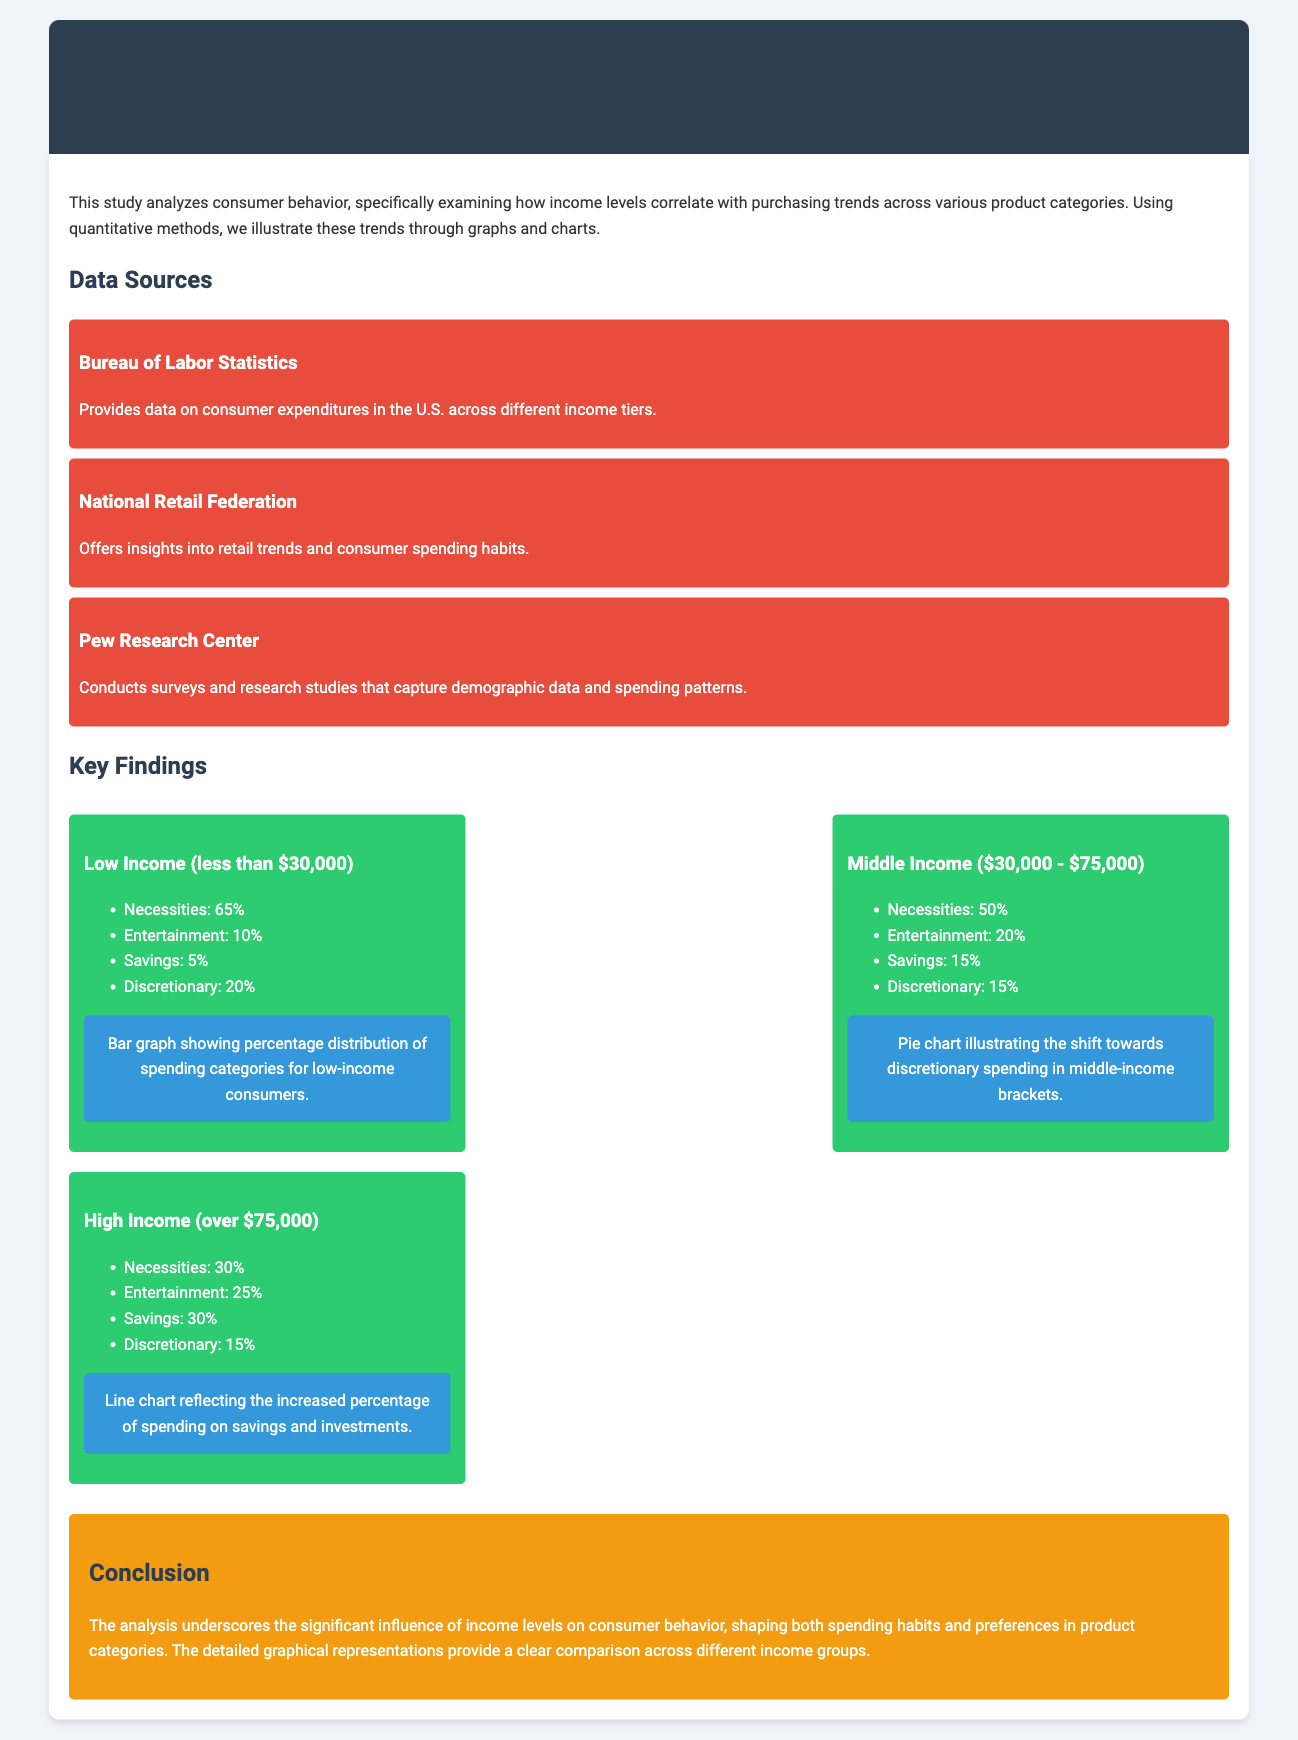What is the primary focus of the study? The study examines how income levels correlate with purchasing trends across various product categories.
Answer: Correlation between income levels and purchasing trends Which data source provides information on consumer expenditures in the U.S.? The document mentions the Bureau of Labor Statistics as a data source for consumer expenditures across income tiers.
Answer: Bureau of Labor Statistics What percentage of low-income consumers spend on necessities? The document states that 65% of low-income consumers allocate their spending to necessities.
Answer: 65% How much do high-income consumers allocate to entertainment? According to the findings, high-income consumers spend 25% on entertainment.
Answer: 25% What spending category sees the highest percentage for middle-income consumers? The analysis reveals that necessities account for 50% of spending among middle-income consumers.
Answer: Necessities Which chart type illustrates the shift towards discretionary spending in middle-income brackets? The document specifies that a pie chart is used to illustrate this shift.
Answer: Pie chart What is the income threshold for the high-income category in the study? The document states that the high-income category includes consumers earning over $75,000.
Answer: Over $75,000 What is the overall conclusion regarding income levels and consumer behavior? The conclusion emphasizes the significant influence of income levels on consumer behavior and spending habits.
Answer: Significant influence on consumer behavior How does high-income spending on savings compare to low-income spending? The findings indicate that high-income consumers spend 30% on savings, while low-income consumers spend 5%.
Answer: High-income: 30%, Low-income: 5% 